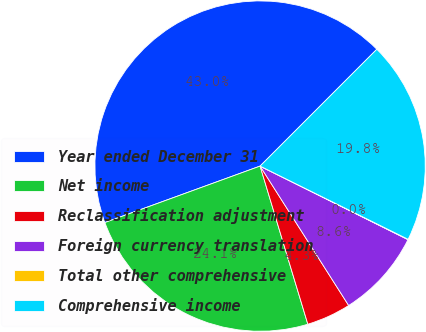<chart> <loc_0><loc_0><loc_500><loc_500><pie_chart><fcel>Year ended December 31<fcel>Net income<fcel>Reclassification adjustment<fcel>Foreign currency translation<fcel>Total other comprehensive<fcel>Comprehensive income<nl><fcel>43.04%<fcel>24.11%<fcel>4.34%<fcel>8.64%<fcel>0.04%<fcel>19.81%<nl></chart> 